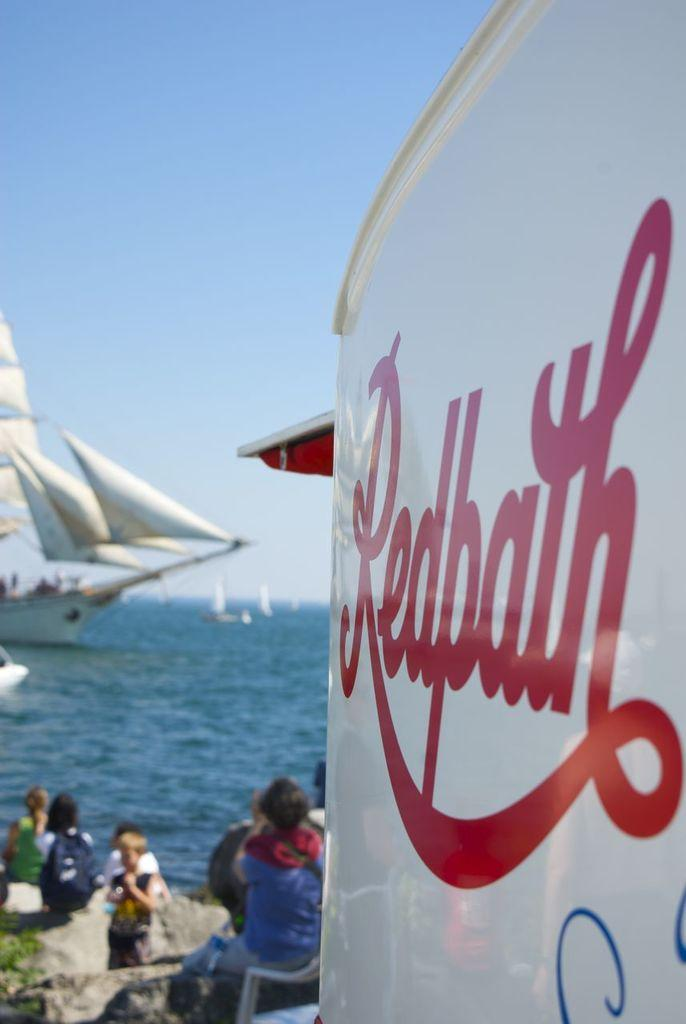<image>
Give a short and clear explanation of the subsequent image. A sign for Redbath can be seen on a beachy area with pristine blue waters 